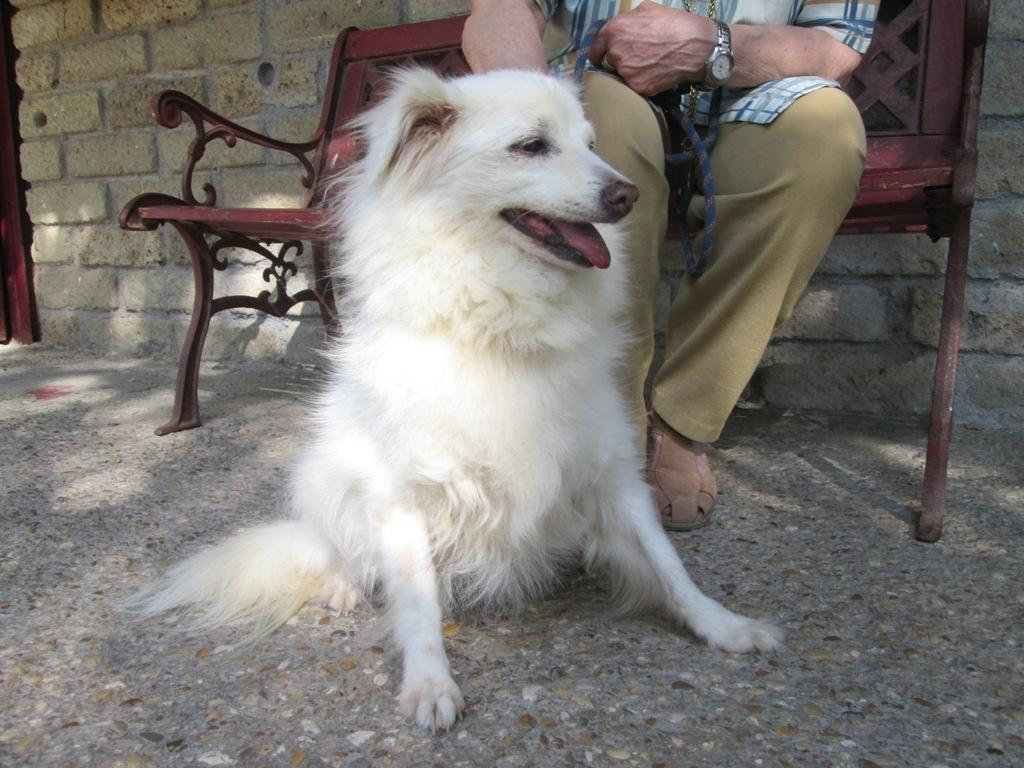What is the person in the image doing? There is a person sitting on a bench in the image. What is the dog in the image doing? There is a dog sitting on the floor in the image. What type of structure can be seen in the background of the image? There is a brick wall in the image. What type of soup is being served in the image? There is no soup present in the image. Can you tell me how many geese are visible in the image? There are no geese visible in the image. 